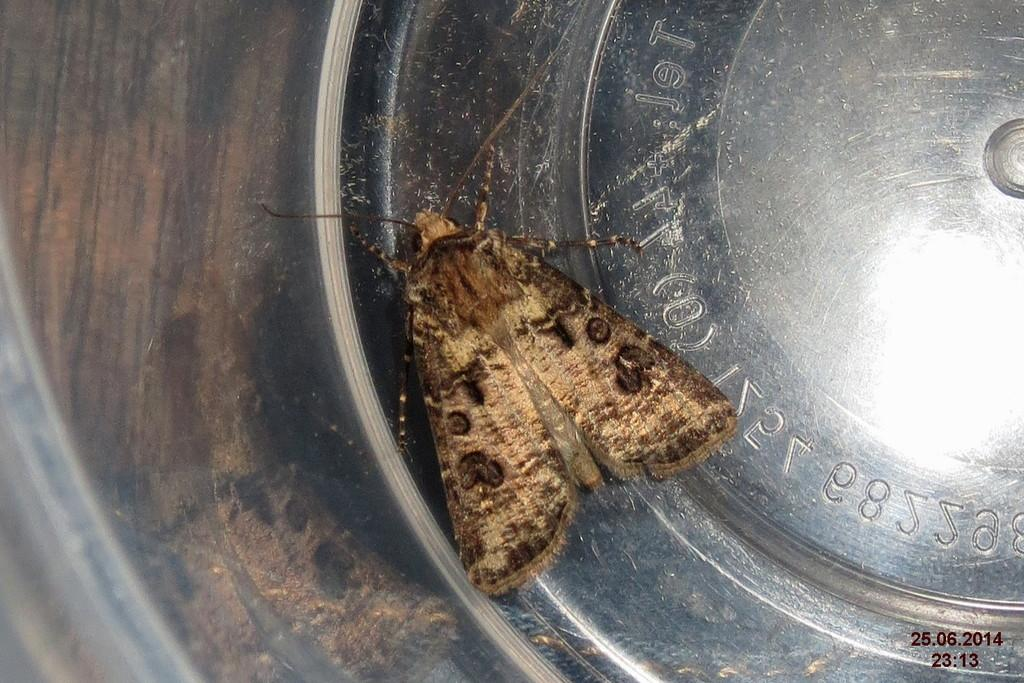What type of object is silver in the image? There is a silver object in the image. Is there any living organism on the silver object? Yes, there is an insect on the silver object. What is the color of the insect? The insect is brown in color. What additional information can be found in the image? There is text written on the image and a watermark. What role does the judge play in the image? There is no judge present in the image. What type of metal is the gold object in the image? There is no gold object present in the image. 